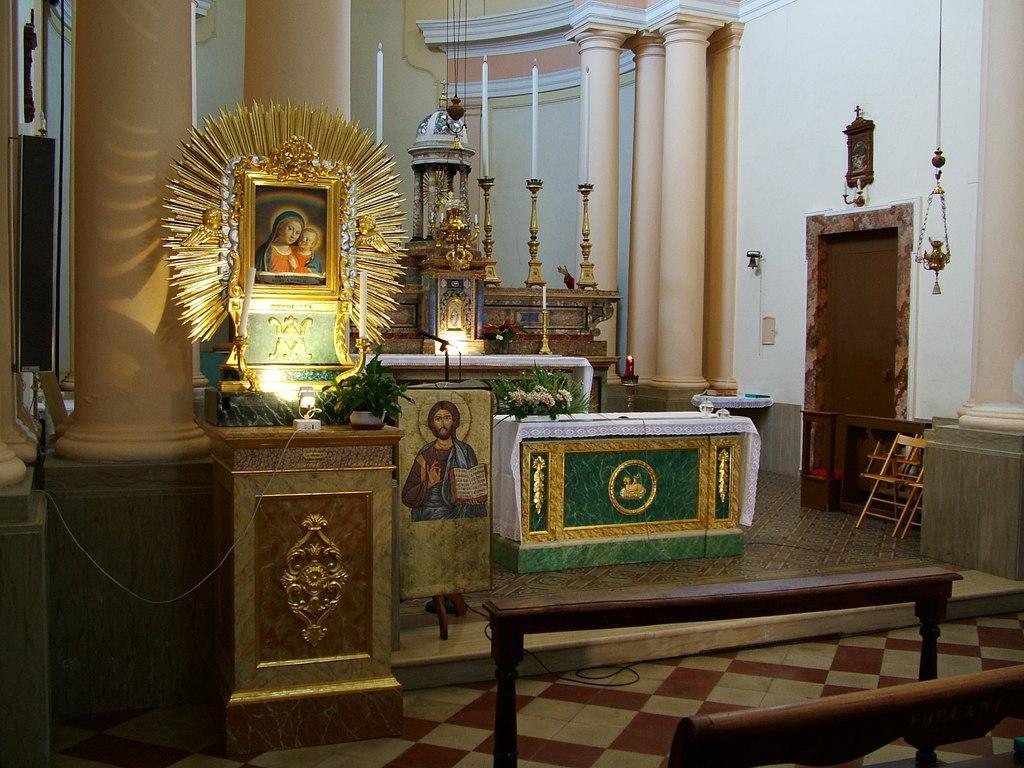In one or two sentences, can you explain what this image depicts? In this image we can see wooden stands. Also there are pillars. And there is a stand. On that there is a photo frame. Also there is flower bouquet. And there are candles with stands. Also there is a painting. And there are few objects hung. 